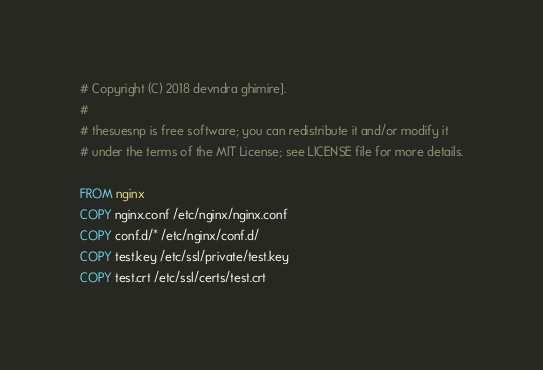Convert code to text. <code><loc_0><loc_0><loc_500><loc_500><_Dockerfile_># Copyright (C) 2018 devndra ghimire].
#
# thesuesnp is free software; you can redistribute it and/or modify it
# under the terms of the MIT License; see LICENSE file for more details.

FROM nginx
COPY nginx.conf /etc/nginx/nginx.conf
COPY conf.d/* /etc/nginx/conf.d/
COPY test.key /etc/ssl/private/test.key
COPY test.crt /etc/ssl/certs/test.crt
</code> 